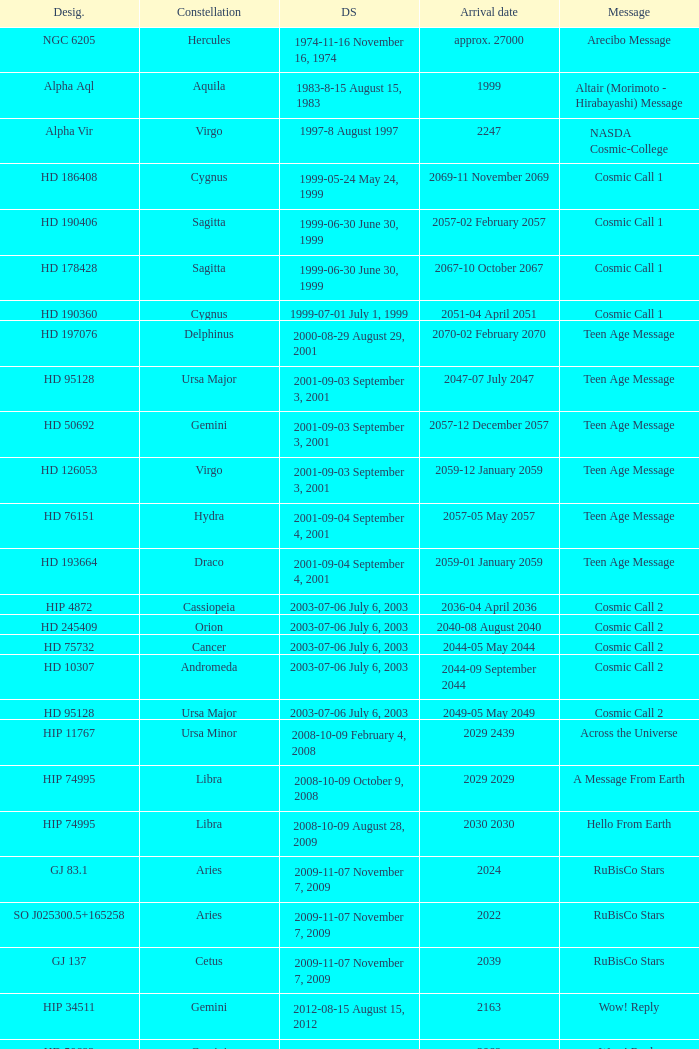Where is Hip 4872? Cassiopeia. 